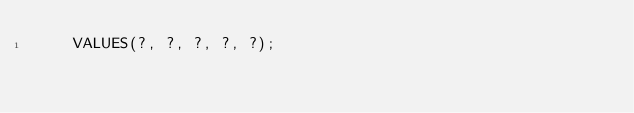<code> <loc_0><loc_0><loc_500><loc_500><_SQL_>    VALUES(?, ?, ?, ?, ?);</code> 